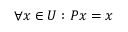Convert formula to latex. <formula><loc_0><loc_0><loc_500><loc_500>\forall x \in U \colon P x = x</formula> 